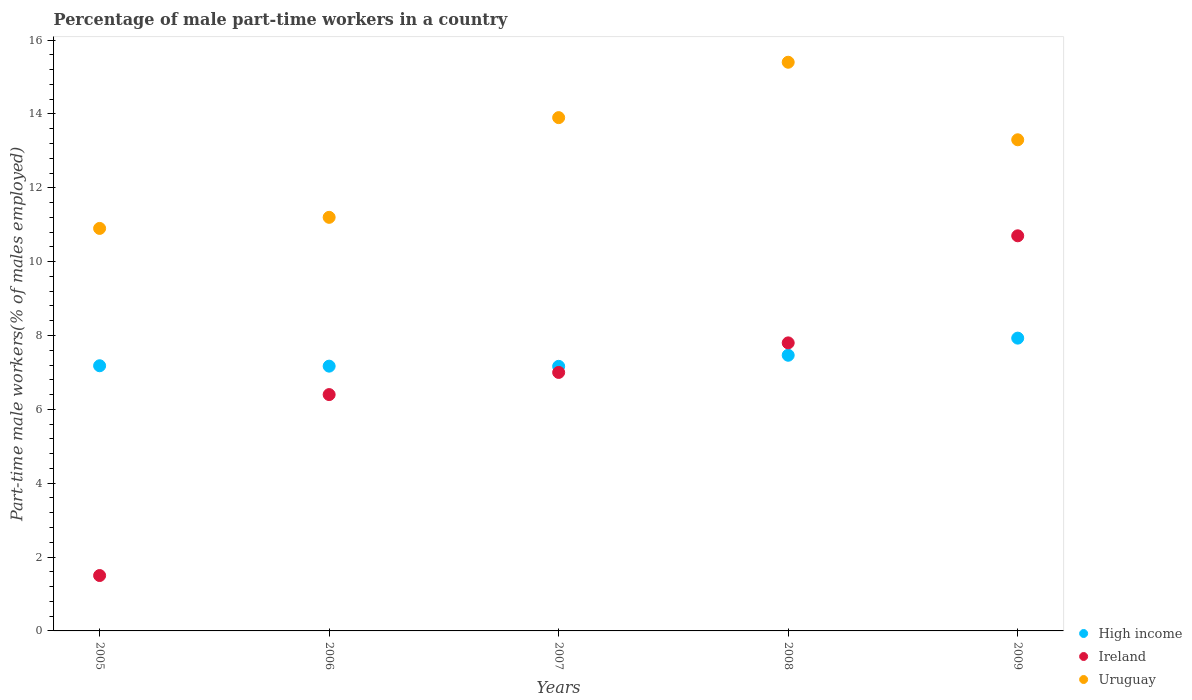How many different coloured dotlines are there?
Provide a succinct answer. 3. What is the percentage of male part-time workers in Uruguay in 2008?
Your response must be concise. 15.4. Across all years, what is the maximum percentage of male part-time workers in High income?
Keep it short and to the point. 7.93. Across all years, what is the minimum percentage of male part-time workers in High income?
Your answer should be compact. 7.16. In which year was the percentage of male part-time workers in Uruguay maximum?
Your answer should be very brief. 2008. What is the total percentage of male part-time workers in Ireland in the graph?
Your answer should be very brief. 33.4. What is the difference between the percentage of male part-time workers in High income in 2006 and that in 2009?
Keep it short and to the point. -0.76. What is the difference between the percentage of male part-time workers in Ireland in 2008 and the percentage of male part-time workers in High income in 2009?
Ensure brevity in your answer.  -0.13. What is the average percentage of male part-time workers in High income per year?
Your answer should be compact. 7.38. In the year 2006, what is the difference between the percentage of male part-time workers in High income and percentage of male part-time workers in Ireland?
Give a very brief answer. 0.77. What is the ratio of the percentage of male part-time workers in Ireland in 2006 to that in 2009?
Make the answer very short. 0.6. Is the difference between the percentage of male part-time workers in High income in 2006 and 2009 greater than the difference between the percentage of male part-time workers in Ireland in 2006 and 2009?
Ensure brevity in your answer.  Yes. What is the difference between the highest and the second highest percentage of male part-time workers in Ireland?
Ensure brevity in your answer.  2.9. Is the sum of the percentage of male part-time workers in Ireland in 2006 and 2008 greater than the maximum percentage of male part-time workers in Uruguay across all years?
Make the answer very short. No. Is it the case that in every year, the sum of the percentage of male part-time workers in Uruguay and percentage of male part-time workers in Ireland  is greater than the percentage of male part-time workers in High income?
Your answer should be very brief. Yes. Does the percentage of male part-time workers in Ireland monotonically increase over the years?
Offer a terse response. Yes. Is the percentage of male part-time workers in Ireland strictly less than the percentage of male part-time workers in Uruguay over the years?
Provide a short and direct response. Yes. How many dotlines are there?
Your answer should be compact. 3. What is the difference between two consecutive major ticks on the Y-axis?
Provide a short and direct response. 2. Does the graph contain grids?
Make the answer very short. No. Where does the legend appear in the graph?
Provide a succinct answer. Bottom right. How many legend labels are there?
Ensure brevity in your answer.  3. What is the title of the graph?
Offer a terse response. Percentage of male part-time workers in a country. What is the label or title of the Y-axis?
Your response must be concise. Part-time male workers(% of males employed). What is the Part-time male workers(% of males employed) of High income in 2005?
Your response must be concise. 7.18. What is the Part-time male workers(% of males employed) of Ireland in 2005?
Your answer should be very brief. 1.5. What is the Part-time male workers(% of males employed) in Uruguay in 2005?
Make the answer very short. 10.9. What is the Part-time male workers(% of males employed) in High income in 2006?
Offer a very short reply. 7.17. What is the Part-time male workers(% of males employed) in Ireland in 2006?
Make the answer very short. 6.4. What is the Part-time male workers(% of males employed) of Uruguay in 2006?
Provide a succinct answer. 11.2. What is the Part-time male workers(% of males employed) in High income in 2007?
Offer a terse response. 7.16. What is the Part-time male workers(% of males employed) in Uruguay in 2007?
Make the answer very short. 13.9. What is the Part-time male workers(% of males employed) in High income in 2008?
Offer a terse response. 7.47. What is the Part-time male workers(% of males employed) of Ireland in 2008?
Ensure brevity in your answer.  7.8. What is the Part-time male workers(% of males employed) of Uruguay in 2008?
Offer a very short reply. 15.4. What is the Part-time male workers(% of males employed) of High income in 2009?
Ensure brevity in your answer.  7.93. What is the Part-time male workers(% of males employed) of Ireland in 2009?
Make the answer very short. 10.7. What is the Part-time male workers(% of males employed) in Uruguay in 2009?
Give a very brief answer. 13.3. Across all years, what is the maximum Part-time male workers(% of males employed) of High income?
Your answer should be compact. 7.93. Across all years, what is the maximum Part-time male workers(% of males employed) in Ireland?
Make the answer very short. 10.7. Across all years, what is the maximum Part-time male workers(% of males employed) in Uruguay?
Provide a succinct answer. 15.4. Across all years, what is the minimum Part-time male workers(% of males employed) of High income?
Offer a terse response. 7.16. Across all years, what is the minimum Part-time male workers(% of males employed) in Ireland?
Provide a succinct answer. 1.5. Across all years, what is the minimum Part-time male workers(% of males employed) of Uruguay?
Your answer should be compact. 10.9. What is the total Part-time male workers(% of males employed) in High income in the graph?
Provide a succinct answer. 36.91. What is the total Part-time male workers(% of males employed) in Ireland in the graph?
Give a very brief answer. 33.4. What is the total Part-time male workers(% of males employed) in Uruguay in the graph?
Offer a very short reply. 64.7. What is the difference between the Part-time male workers(% of males employed) in High income in 2005 and that in 2006?
Provide a short and direct response. 0.01. What is the difference between the Part-time male workers(% of males employed) of High income in 2005 and that in 2007?
Offer a terse response. 0.02. What is the difference between the Part-time male workers(% of males employed) of High income in 2005 and that in 2008?
Give a very brief answer. -0.28. What is the difference between the Part-time male workers(% of males employed) in High income in 2005 and that in 2009?
Your answer should be very brief. -0.75. What is the difference between the Part-time male workers(% of males employed) of Ireland in 2005 and that in 2009?
Your response must be concise. -9.2. What is the difference between the Part-time male workers(% of males employed) in Uruguay in 2005 and that in 2009?
Give a very brief answer. -2.4. What is the difference between the Part-time male workers(% of males employed) in High income in 2006 and that in 2007?
Make the answer very short. 0.01. What is the difference between the Part-time male workers(% of males employed) of High income in 2006 and that in 2008?
Make the answer very short. -0.3. What is the difference between the Part-time male workers(% of males employed) in High income in 2006 and that in 2009?
Provide a short and direct response. -0.76. What is the difference between the Part-time male workers(% of males employed) in High income in 2007 and that in 2008?
Your answer should be compact. -0.3. What is the difference between the Part-time male workers(% of males employed) in Uruguay in 2007 and that in 2008?
Offer a terse response. -1.5. What is the difference between the Part-time male workers(% of males employed) of High income in 2007 and that in 2009?
Ensure brevity in your answer.  -0.76. What is the difference between the Part-time male workers(% of males employed) in High income in 2008 and that in 2009?
Your response must be concise. -0.46. What is the difference between the Part-time male workers(% of males employed) of Uruguay in 2008 and that in 2009?
Your answer should be compact. 2.1. What is the difference between the Part-time male workers(% of males employed) of High income in 2005 and the Part-time male workers(% of males employed) of Ireland in 2006?
Your response must be concise. 0.78. What is the difference between the Part-time male workers(% of males employed) in High income in 2005 and the Part-time male workers(% of males employed) in Uruguay in 2006?
Make the answer very short. -4.02. What is the difference between the Part-time male workers(% of males employed) of High income in 2005 and the Part-time male workers(% of males employed) of Ireland in 2007?
Your answer should be compact. 0.18. What is the difference between the Part-time male workers(% of males employed) of High income in 2005 and the Part-time male workers(% of males employed) of Uruguay in 2007?
Offer a very short reply. -6.72. What is the difference between the Part-time male workers(% of males employed) of Ireland in 2005 and the Part-time male workers(% of males employed) of Uruguay in 2007?
Keep it short and to the point. -12.4. What is the difference between the Part-time male workers(% of males employed) in High income in 2005 and the Part-time male workers(% of males employed) in Ireland in 2008?
Keep it short and to the point. -0.62. What is the difference between the Part-time male workers(% of males employed) of High income in 2005 and the Part-time male workers(% of males employed) of Uruguay in 2008?
Provide a succinct answer. -8.22. What is the difference between the Part-time male workers(% of males employed) of High income in 2005 and the Part-time male workers(% of males employed) of Ireland in 2009?
Offer a terse response. -3.52. What is the difference between the Part-time male workers(% of males employed) in High income in 2005 and the Part-time male workers(% of males employed) in Uruguay in 2009?
Your response must be concise. -6.12. What is the difference between the Part-time male workers(% of males employed) in High income in 2006 and the Part-time male workers(% of males employed) in Ireland in 2007?
Your answer should be very brief. 0.17. What is the difference between the Part-time male workers(% of males employed) of High income in 2006 and the Part-time male workers(% of males employed) of Uruguay in 2007?
Ensure brevity in your answer.  -6.73. What is the difference between the Part-time male workers(% of males employed) of High income in 2006 and the Part-time male workers(% of males employed) of Ireland in 2008?
Provide a succinct answer. -0.63. What is the difference between the Part-time male workers(% of males employed) of High income in 2006 and the Part-time male workers(% of males employed) of Uruguay in 2008?
Your answer should be compact. -8.23. What is the difference between the Part-time male workers(% of males employed) in Ireland in 2006 and the Part-time male workers(% of males employed) in Uruguay in 2008?
Make the answer very short. -9. What is the difference between the Part-time male workers(% of males employed) of High income in 2006 and the Part-time male workers(% of males employed) of Ireland in 2009?
Provide a succinct answer. -3.53. What is the difference between the Part-time male workers(% of males employed) in High income in 2006 and the Part-time male workers(% of males employed) in Uruguay in 2009?
Ensure brevity in your answer.  -6.13. What is the difference between the Part-time male workers(% of males employed) in High income in 2007 and the Part-time male workers(% of males employed) in Ireland in 2008?
Your response must be concise. -0.64. What is the difference between the Part-time male workers(% of males employed) of High income in 2007 and the Part-time male workers(% of males employed) of Uruguay in 2008?
Provide a succinct answer. -8.23. What is the difference between the Part-time male workers(% of males employed) in Ireland in 2007 and the Part-time male workers(% of males employed) in Uruguay in 2008?
Make the answer very short. -8.4. What is the difference between the Part-time male workers(% of males employed) in High income in 2007 and the Part-time male workers(% of males employed) in Ireland in 2009?
Your answer should be very brief. -3.54. What is the difference between the Part-time male workers(% of males employed) in High income in 2007 and the Part-time male workers(% of males employed) in Uruguay in 2009?
Keep it short and to the point. -6.13. What is the difference between the Part-time male workers(% of males employed) of High income in 2008 and the Part-time male workers(% of males employed) of Ireland in 2009?
Your answer should be very brief. -3.23. What is the difference between the Part-time male workers(% of males employed) of High income in 2008 and the Part-time male workers(% of males employed) of Uruguay in 2009?
Ensure brevity in your answer.  -5.83. What is the difference between the Part-time male workers(% of males employed) in Ireland in 2008 and the Part-time male workers(% of males employed) in Uruguay in 2009?
Offer a terse response. -5.5. What is the average Part-time male workers(% of males employed) in High income per year?
Offer a very short reply. 7.38. What is the average Part-time male workers(% of males employed) of Ireland per year?
Make the answer very short. 6.68. What is the average Part-time male workers(% of males employed) of Uruguay per year?
Keep it short and to the point. 12.94. In the year 2005, what is the difference between the Part-time male workers(% of males employed) in High income and Part-time male workers(% of males employed) in Ireland?
Ensure brevity in your answer.  5.68. In the year 2005, what is the difference between the Part-time male workers(% of males employed) in High income and Part-time male workers(% of males employed) in Uruguay?
Keep it short and to the point. -3.72. In the year 2006, what is the difference between the Part-time male workers(% of males employed) of High income and Part-time male workers(% of males employed) of Ireland?
Your response must be concise. 0.77. In the year 2006, what is the difference between the Part-time male workers(% of males employed) of High income and Part-time male workers(% of males employed) of Uruguay?
Your answer should be compact. -4.03. In the year 2006, what is the difference between the Part-time male workers(% of males employed) of Ireland and Part-time male workers(% of males employed) of Uruguay?
Ensure brevity in your answer.  -4.8. In the year 2007, what is the difference between the Part-time male workers(% of males employed) of High income and Part-time male workers(% of males employed) of Ireland?
Provide a short and direct response. 0.17. In the year 2007, what is the difference between the Part-time male workers(% of males employed) of High income and Part-time male workers(% of males employed) of Uruguay?
Your answer should be very brief. -6.74. In the year 2007, what is the difference between the Part-time male workers(% of males employed) of Ireland and Part-time male workers(% of males employed) of Uruguay?
Your answer should be very brief. -6.9. In the year 2008, what is the difference between the Part-time male workers(% of males employed) in High income and Part-time male workers(% of males employed) in Ireland?
Keep it short and to the point. -0.33. In the year 2008, what is the difference between the Part-time male workers(% of males employed) of High income and Part-time male workers(% of males employed) of Uruguay?
Your answer should be compact. -7.93. In the year 2009, what is the difference between the Part-time male workers(% of males employed) in High income and Part-time male workers(% of males employed) in Ireland?
Your answer should be compact. -2.77. In the year 2009, what is the difference between the Part-time male workers(% of males employed) in High income and Part-time male workers(% of males employed) in Uruguay?
Make the answer very short. -5.37. In the year 2009, what is the difference between the Part-time male workers(% of males employed) in Ireland and Part-time male workers(% of males employed) in Uruguay?
Provide a short and direct response. -2.6. What is the ratio of the Part-time male workers(% of males employed) in High income in 2005 to that in 2006?
Provide a short and direct response. 1. What is the ratio of the Part-time male workers(% of males employed) of Ireland in 2005 to that in 2006?
Your answer should be very brief. 0.23. What is the ratio of the Part-time male workers(% of males employed) in Uruguay in 2005 to that in 2006?
Offer a terse response. 0.97. What is the ratio of the Part-time male workers(% of males employed) in Ireland in 2005 to that in 2007?
Keep it short and to the point. 0.21. What is the ratio of the Part-time male workers(% of males employed) in Uruguay in 2005 to that in 2007?
Offer a very short reply. 0.78. What is the ratio of the Part-time male workers(% of males employed) of High income in 2005 to that in 2008?
Offer a terse response. 0.96. What is the ratio of the Part-time male workers(% of males employed) in Ireland in 2005 to that in 2008?
Offer a very short reply. 0.19. What is the ratio of the Part-time male workers(% of males employed) of Uruguay in 2005 to that in 2008?
Your answer should be compact. 0.71. What is the ratio of the Part-time male workers(% of males employed) of High income in 2005 to that in 2009?
Your response must be concise. 0.91. What is the ratio of the Part-time male workers(% of males employed) in Ireland in 2005 to that in 2009?
Your answer should be very brief. 0.14. What is the ratio of the Part-time male workers(% of males employed) of Uruguay in 2005 to that in 2009?
Provide a succinct answer. 0.82. What is the ratio of the Part-time male workers(% of males employed) in High income in 2006 to that in 2007?
Make the answer very short. 1. What is the ratio of the Part-time male workers(% of males employed) in Ireland in 2006 to that in 2007?
Your answer should be compact. 0.91. What is the ratio of the Part-time male workers(% of males employed) of Uruguay in 2006 to that in 2007?
Offer a very short reply. 0.81. What is the ratio of the Part-time male workers(% of males employed) in High income in 2006 to that in 2008?
Your answer should be very brief. 0.96. What is the ratio of the Part-time male workers(% of males employed) in Ireland in 2006 to that in 2008?
Your answer should be compact. 0.82. What is the ratio of the Part-time male workers(% of males employed) in Uruguay in 2006 to that in 2008?
Your response must be concise. 0.73. What is the ratio of the Part-time male workers(% of males employed) in High income in 2006 to that in 2009?
Keep it short and to the point. 0.9. What is the ratio of the Part-time male workers(% of males employed) in Ireland in 2006 to that in 2009?
Give a very brief answer. 0.6. What is the ratio of the Part-time male workers(% of males employed) in Uruguay in 2006 to that in 2009?
Provide a short and direct response. 0.84. What is the ratio of the Part-time male workers(% of males employed) in High income in 2007 to that in 2008?
Offer a very short reply. 0.96. What is the ratio of the Part-time male workers(% of males employed) in Ireland in 2007 to that in 2008?
Your response must be concise. 0.9. What is the ratio of the Part-time male workers(% of males employed) of Uruguay in 2007 to that in 2008?
Give a very brief answer. 0.9. What is the ratio of the Part-time male workers(% of males employed) in High income in 2007 to that in 2009?
Your answer should be very brief. 0.9. What is the ratio of the Part-time male workers(% of males employed) in Ireland in 2007 to that in 2009?
Your answer should be compact. 0.65. What is the ratio of the Part-time male workers(% of males employed) of Uruguay in 2007 to that in 2009?
Provide a short and direct response. 1.05. What is the ratio of the Part-time male workers(% of males employed) in High income in 2008 to that in 2009?
Offer a very short reply. 0.94. What is the ratio of the Part-time male workers(% of males employed) in Ireland in 2008 to that in 2009?
Provide a short and direct response. 0.73. What is the ratio of the Part-time male workers(% of males employed) in Uruguay in 2008 to that in 2009?
Ensure brevity in your answer.  1.16. What is the difference between the highest and the second highest Part-time male workers(% of males employed) of High income?
Your response must be concise. 0.46. What is the difference between the highest and the second highest Part-time male workers(% of males employed) in Uruguay?
Give a very brief answer. 1.5. What is the difference between the highest and the lowest Part-time male workers(% of males employed) of High income?
Provide a succinct answer. 0.76. What is the difference between the highest and the lowest Part-time male workers(% of males employed) in Uruguay?
Keep it short and to the point. 4.5. 